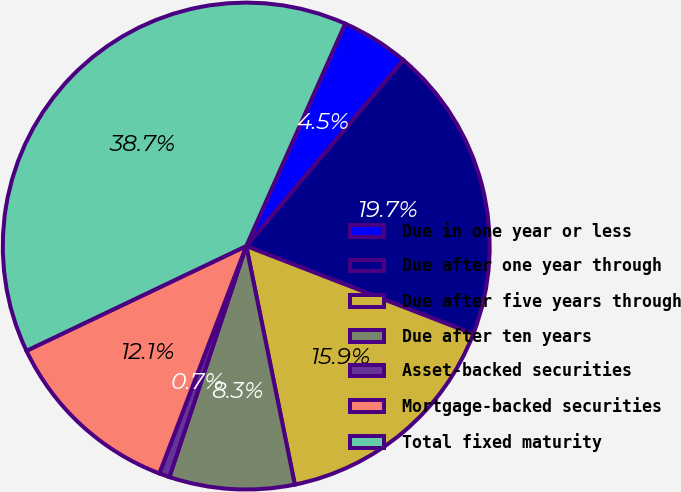<chart> <loc_0><loc_0><loc_500><loc_500><pie_chart><fcel>Due in one year or less<fcel>Due after one year through<fcel>Due after five years through<fcel>Due after ten years<fcel>Asset-backed securities<fcel>Mortgage-backed securities<fcel>Total fixed maturity<nl><fcel>4.5%<fcel>19.72%<fcel>15.92%<fcel>8.31%<fcel>0.7%<fcel>12.11%<fcel>38.74%<nl></chart> 